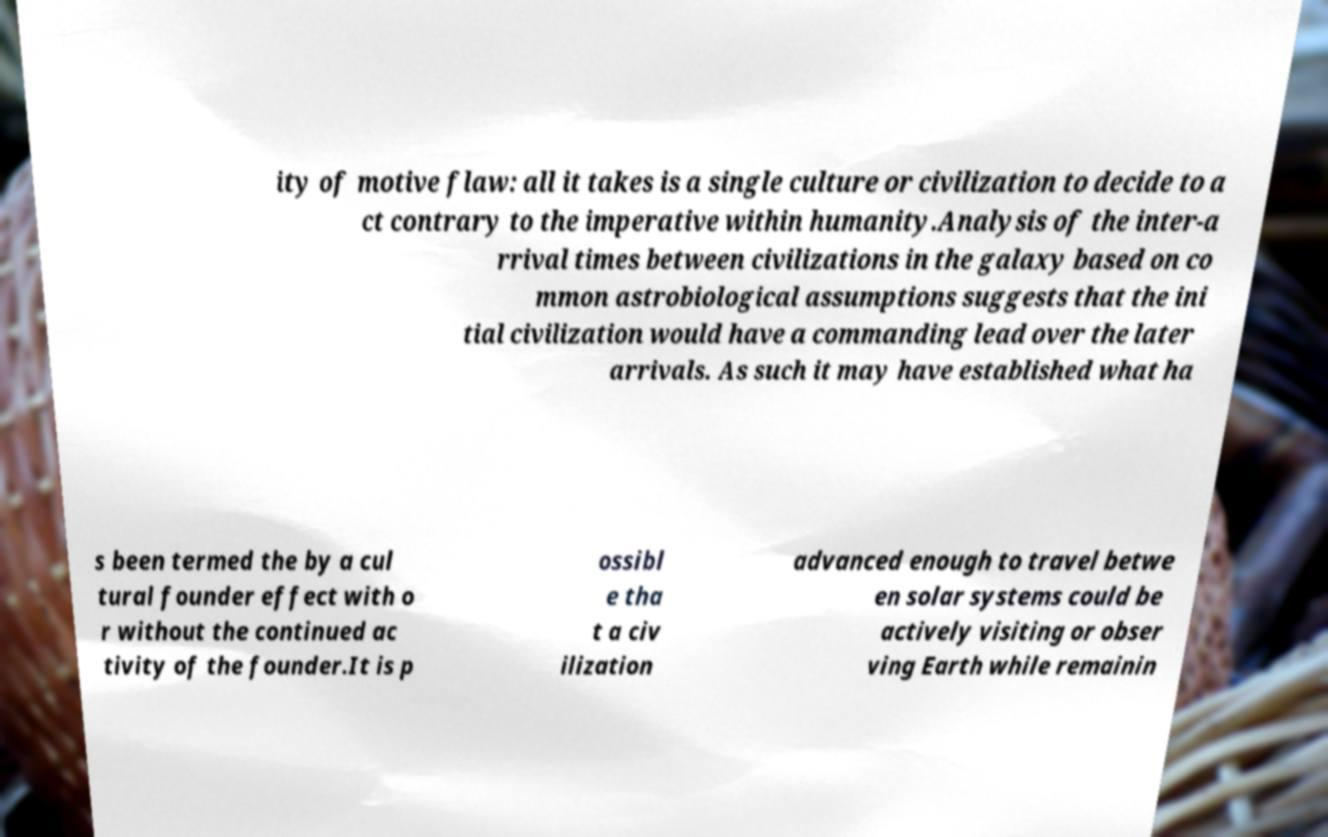I need the written content from this picture converted into text. Can you do that? ity of motive flaw: all it takes is a single culture or civilization to decide to a ct contrary to the imperative within humanity.Analysis of the inter-a rrival times between civilizations in the galaxy based on co mmon astrobiological assumptions suggests that the ini tial civilization would have a commanding lead over the later arrivals. As such it may have established what ha s been termed the by a cul tural founder effect with o r without the continued ac tivity of the founder.It is p ossibl e tha t a civ ilization advanced enough to travel betwe en solar systems could be actively visiting or obser ving Earth while remainin 